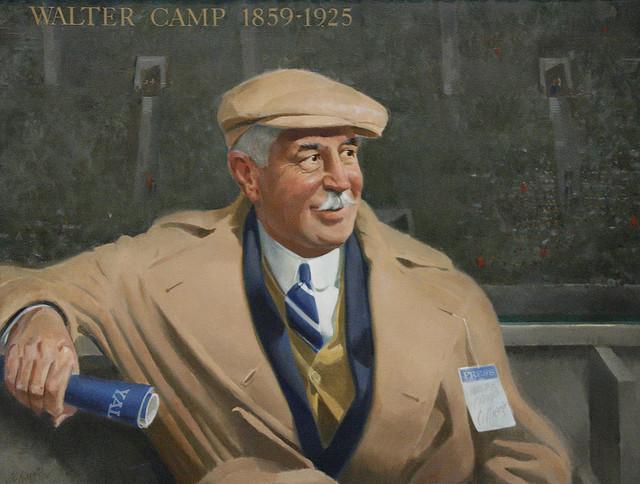What is the man wearing?
Quick response, please. Jacket. Is the man wearing a winter coat?
Answer briefly. Yes. Is this man real?
Short answer required. No. 